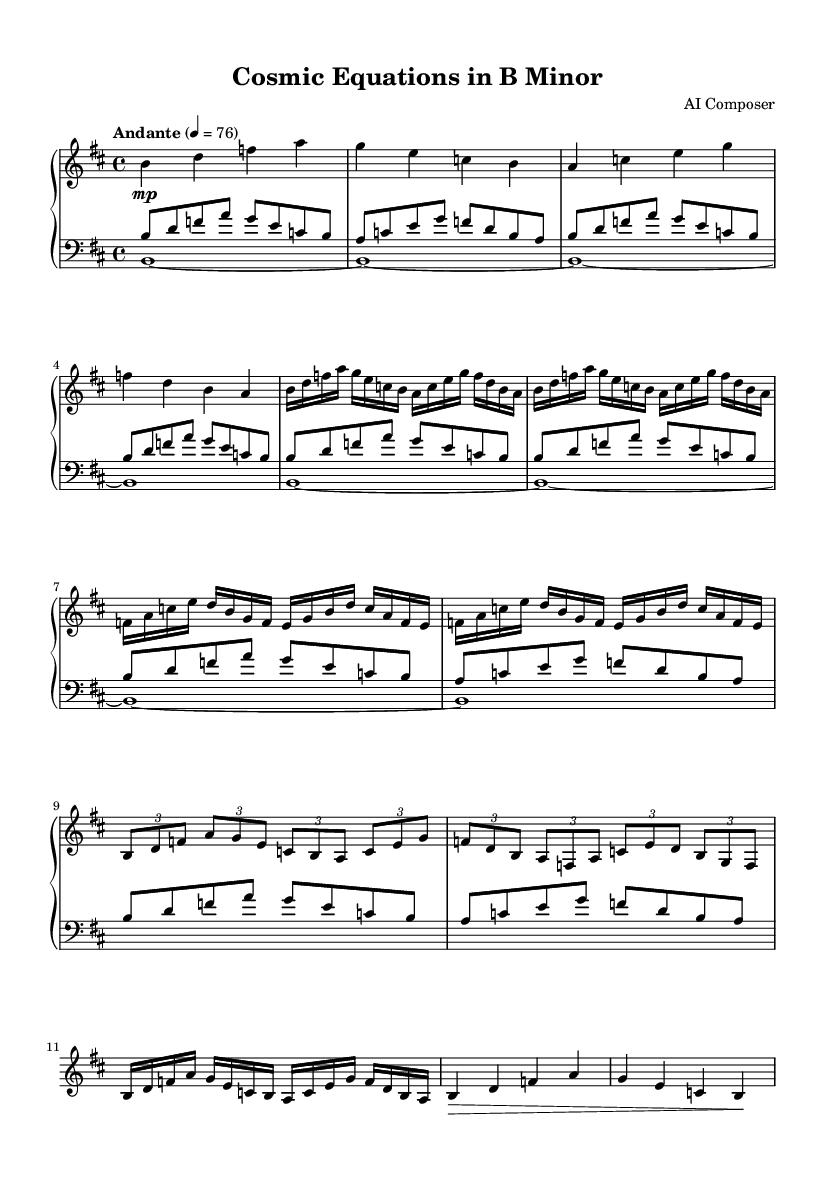What is the key signature of this music? The key signature is indicated by the presence of five sharps at the beginning of the staff, which corresponds to B minor.
Answer: B minor What is the time signature of this music? The time signature is found at the beginning of the piece and is represented by the two numbers stacked on top, indicating each measure has four beats.
Answer: 4/4 What is the tempo marking for this piece? The tempo marking is written above the staff, indicating the speed of the music; it shows "Andante" at a quarter note equals seventy-six beats per minute.
Answer: Andante How many times is Theme A repeated? The number of repetitions can be seen through the repeat signs and the written instructions, which states "repeat unfold 2" for Theme A.
Answer: 2 Which section comes after the development? By looking at the structure, the section that follows the development is labeled as the recapitulation, where themes are revisited.
Answer: Recapitulation What is the dynamics marking for the introduction section? The dynamics markings are shown by symbols next to the notes; in the introduction, it indicates a soft volume marked by "mp."
Answer: mp In what key does the piece modulate towards in the development section? To understand modulations, one needs to examine the notes used in the development section; it predominantly uses notes from B minor but introduces chords that suggest a strong resolution back to B minor.
Answer: B minor 